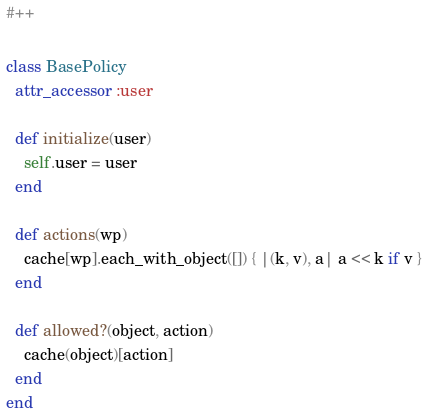Convert code to text. <code><loc_0><loc_0><loc_500><loc_500><_Ruby_>#++

class BasePolicy
  attr_accessor :user

  def initialize(user)
    self.user = user
  end

  def actions(wp)
    cache[wp].each_with_object([]) { |(k, v), a| a << k if v }
  end

  def allowed?(object, action)
    cache(object)[action]
  end
end
</code> 